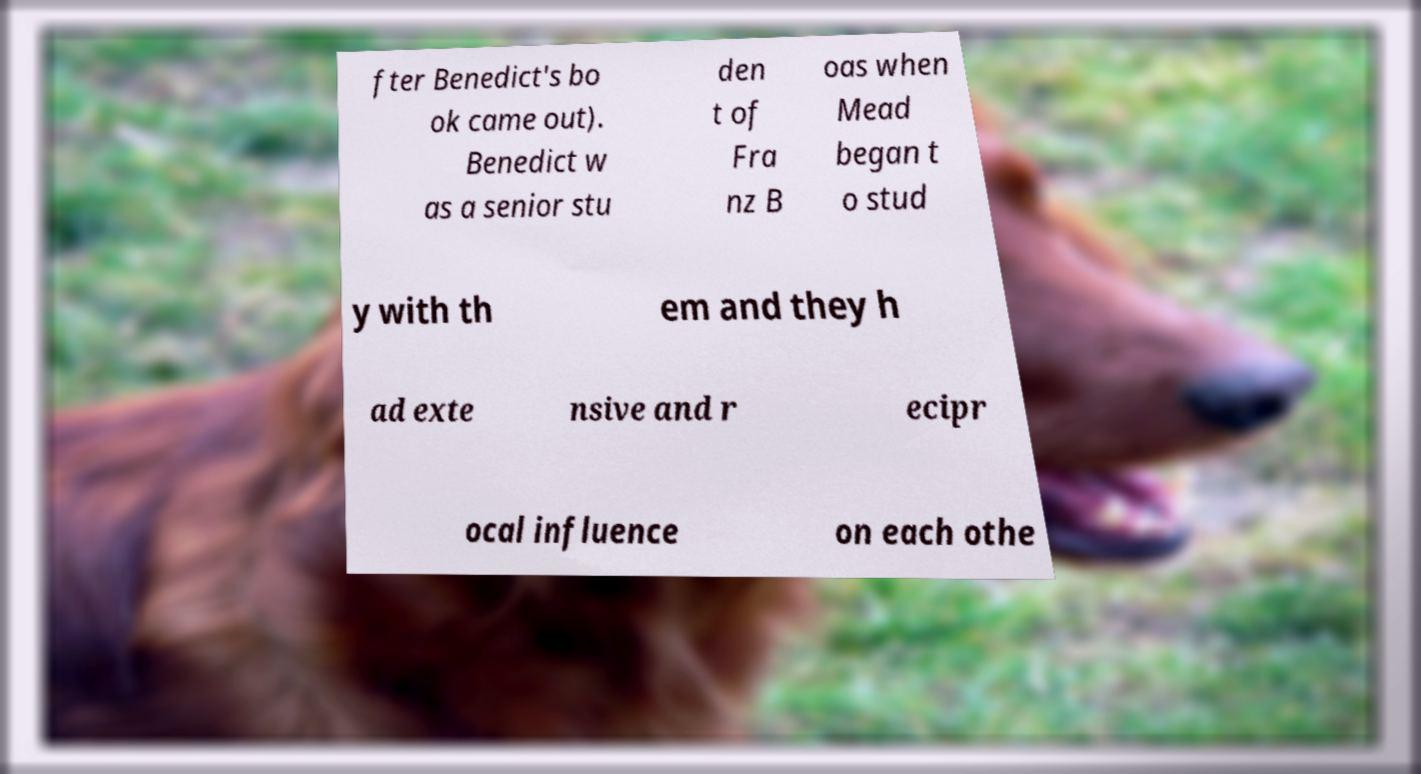What messages or text are displayed in this image? I need them in a readable, typed format. fter Benedict's bo ok came out). Benedict w as a senior stu den t of Fra nz B oas when Mead began t o stud y with th em and they h ad exte nsive and r ecipr ocal influence on each othe 